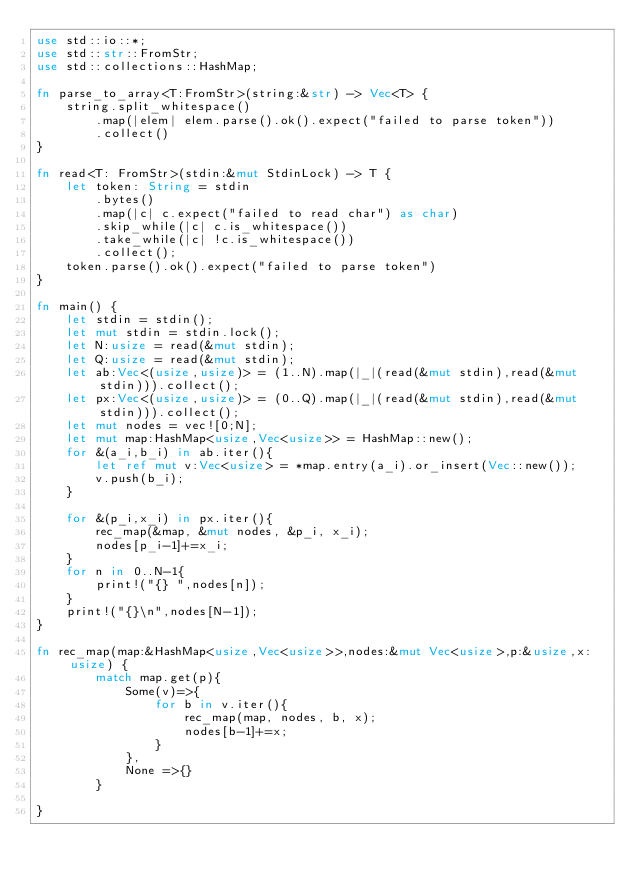<code> <loc_0><loc_0><loc_500><loc_500><_Rust_>use std::io::*;
use std::str::FromStr;
use std::collections::HashMap;

fn parse_to_array<T:FromStr>(string:&str) -> Vec<T> {
    string.split_whitespace()
        .map(|elem| elem.parse().ok().expect("failed to parse token"))
        .collect()
}

fn read<T: FromStr>(stdin:&mut StdinLock) -> T {
    let token: String = stdin
        .bytes()
        .map(|c| c.expect("failed to read char") as char) 
        .skip_while(|c| c.is_whitespace())
        .take_while(|c| !c.is_whitespace())
        .collect();
    token.parse().ok().expect("failed to parse token")
}

fn main() {
    let stdin = stdin();
    let mut stdin = stdin.lock();
    let N:usize = read(&mut stdin);
    let Q:usize = read(&mut stdin);
    let ab:Vec<(usize,usize)> = (1..N).map(|_|(read(&mut stdin),read(&mut stdin))).collect();
    let px:Vec<(usize,usize)> = (0..Q).map(|_|(read(&mut stdin),read(&mut stdin))).collect();
    let mut nodes = vec![0;N];
    let mut map:HashMap<usize,Vec<usize>> = HashMap::new();
    for &(a_i,b_i) in ab.iter(){
        let ref mut v:Vec<usize> = *map.entry(a_i).or_insert(Vec::new());
        v.push(b_i);
    }

    for &(p_i,x_i) in px.iter(){
        rec_map(&map, &mut nodes, &p_i, x_i);
        nodes[p_i-1]+=x_i;
    }
    for n in 0..N-1{
        print!("{} ",nodes[n]);
    }
    print!("{}\n",nodes[N-1]);
}

fn rec_map(map:&HashMap<usize,Vec<usize>>,nodes:&mut Vec<usize>,p:&usize,x:usize) {
        match map.get(p){
            Some(v)=>{
                for b in v.iter(){
                    rec_map(map, nodes, b, x);
                    nodes[b-1]+=x;
                }
            },
            None =>{}
        }
    
}
</code> 